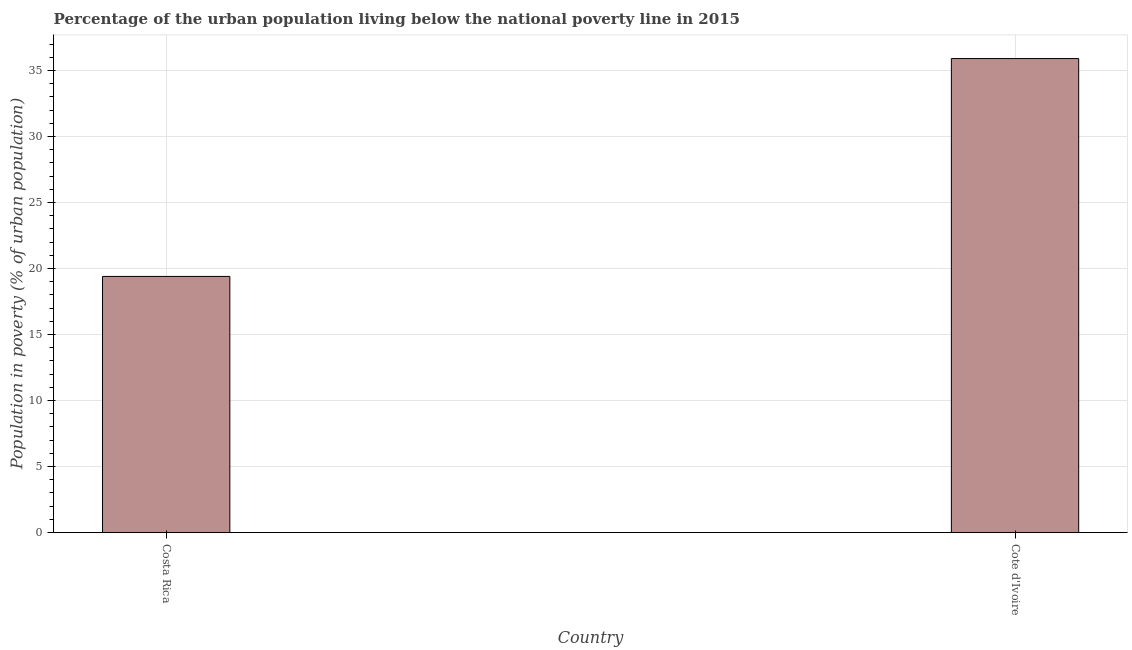Does the graph contain grids?
Provide a short and direct response. Yes. What is the title of the graph?
Ensure brevity in your answer.  Percentage of the urban population living below the national poverty line in 2015. What is the label or title of the X-axis?
Your answer should be compact. Country. What is the label or title of the Y-axis?
Give a very brief answer. Population in poverty (% of urban population). Across all countries, what is the maximum percentage of urban population living below poverty line?
Your response must be concise. 35.9. Across all countries, what is the minimum percentage of urban population living below poverty line?
Provide a succinct answer. 19.4. In which country was the percentage of urban population living below poverty line maximum?
Offer a very short reply. Cote d'Ivoire. What is the sum of the percentage of urban population living below poverty line?
Make the answer very short. 55.3. What is the difference between the percentage of urban population living below poverty line in Costa Rica and Cote d'Ivoire?
Make the answer very short. -16.5. What is the average percentage of urban population living below poverty line per country?
Offer a terse response. 27.65. What is the median percentage of urban population living below poverty line?
Provide a succinct answer. 27.65. What is the ratio of the percentage of urban population living below poverty line in Costa Rica to that in Cote d'Ivoire?
Make the answer very short. 0.54. Is the percentage of urban population living below poverty line in Costa Rica less than that in Cote d'Ivoire?
Offer a very short reply. Yes. In how many countries, is the percentage of urban population living below poverty line greater than the average percentage of urban population living below poverty line taken over all countries?
Your answer should be compact. 1. How many bars are there?
Your answer should be very brief. 2. Are all the bars in the graph horizontal?
Make the answer very short. No. How many countries are there in the graph?
Your answer should be compact. 2. What is the difference between two consecutive major ticks on the Y-axis?
Ensure brevity in your answer.  5. What is the Population in poverty (% of urban population) in Costa Rica?
Make the answer very short. 19.4. What is the Population in poverty (% of urban population) in Cote d'Ivoire?
Your response must be concise. 35.9. What is the difference between the Population in poverty (% of urban population) in Costa Rica and Cote d'Ivoire?
Ensure brevity in your answer.  -16.5. What is the ratio of the Population in poverty (% of urban population) in Costa Rica to that in Cote d'Ivoire?
Your response must be concise. 0.54. 